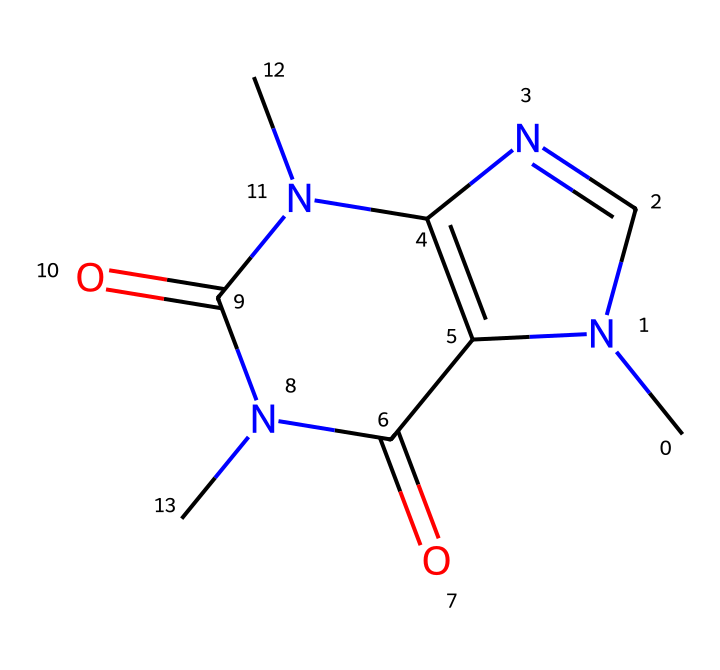What is the molecular formula of caffeine? To determine the molecular formula from the SMILES representation, we can identify the atoms present: 8 carbons (C), 10 hydrogens (H), 4 nitrogens (N), and 2 oxygens (O). Combining these gives us C8H10N4O2.
Answer: C8H10N4O2 How many nitrogen atoms are present in caffeine? By analyzing the SMILES representation, we can count the nitrogen (N) atoms; there are four occurrences of nitrogen in the structure.
Answer: 4 What type of bonding is predominant in caffeine? The SMILES structure reveals multiple covalent bonds between atoms (C, N, O). In organic molecules like caffeine, covalent bonds are the most prevalent.
Answer: covalent Is caffeine a polar or nonpolar molecule? The presence of nitrogen and oxygen, which are more electronegative than carbon and hydrogen, indicates that caffeine is polar due to its distribution of electron density.
Answer: polar What functional groups are present in caffeine? On inspecting the structure, caffeine contains both amine groups (due to nitrogen) and carbonyl groups (due to oxygen double-bonded to carbon), characteristic of its classification as an alkaloid.
Answer: amine and carbonyl What is the total number of rings in the caffeine structure? From the visual breakdown of the chemical structure, caffeine features two fused rings in its design, indicating it has two ring structures.
Answer: 2 Which atom primarily affects caffeine's basicity? The presence of nitrogen atoms, particularly those in amine functional groups, contributes significantly to the basic nature of caffeine, which is critical for its physiological effects.
Answer: nitrogen 